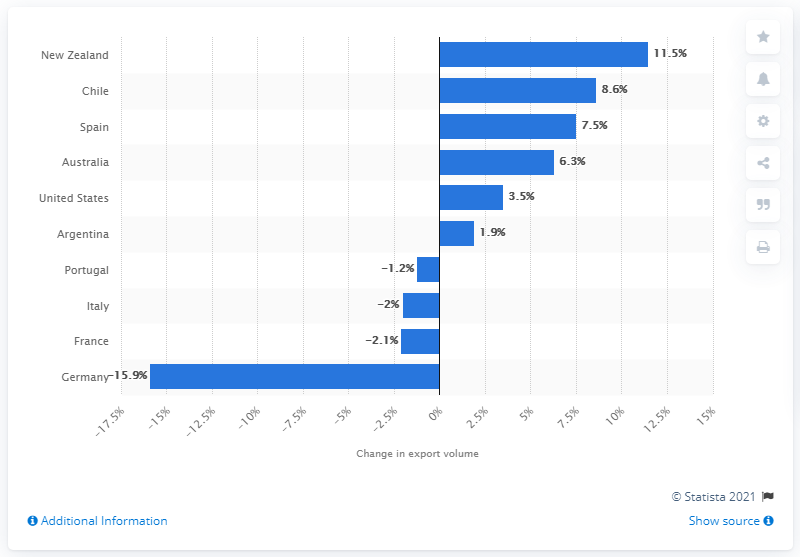Highlight a few significant elements in this photo. Australia's wine export volume increased by 6.3% from 2014 to 2015. The export volume of Spain's wine grew by 7.5% during the period considered. 